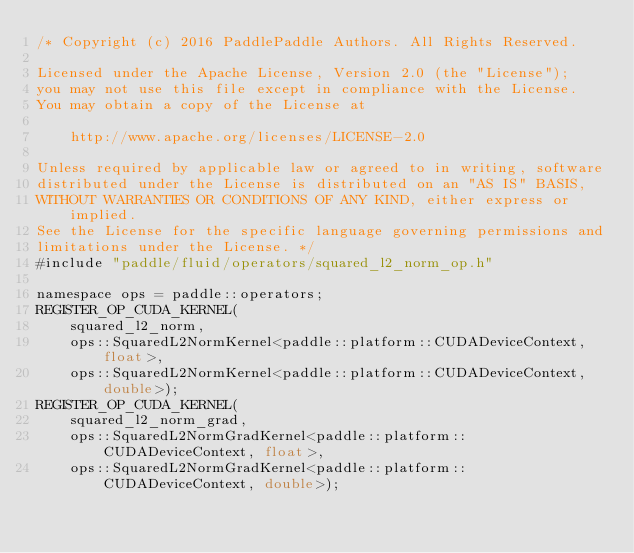Convert code to text. <code><loc_0><loc_0><loc_500><loc_500><_Cuda_>/* Copyright (c) 2016 PaddlePaddle Authors. All Rights Reserved.

Licensed under the Apache License, Version 2.0 (the "License");
you may not use this file except in compliance with the License.
You may obtain a copy of the License at

    http://www.apache.org/licenses/LICENSE-2.0

Unless required by applicable law or agreed to in writing, software
distributed under the License is distributed on an "AS IS" BASIS,
WITHOUT WARRANTIES OR CONDITIONS OF ANY KIND, either express or implied.
See the License for the specific language governing permissions and
limitations under the License. */
#include "paddle/fluid/operators/squared_l2_norm_op.h"

namespace ops = paddle::operators;
REGISTER_OP_CUDA_KERNEL(
    squared_l2_norm,
    ops::SquaredL2NormKernel<paddle::platform::CUDADeviceContext, float>,
    ops::SquaredL2NormKernel<paddle::platform::CUDADeviceContext, double>);
REGISTER_OP_CUDA_KERNEL(
    squared_l2_norm_grad,
    ops::SquaredL2NormGradKernel<paddle::platform::CUDADeviceContext, float>,
    ops::SquaredL2NormGradKernel<paddle::platform::CUDADeviceContext, double>);
</code> 